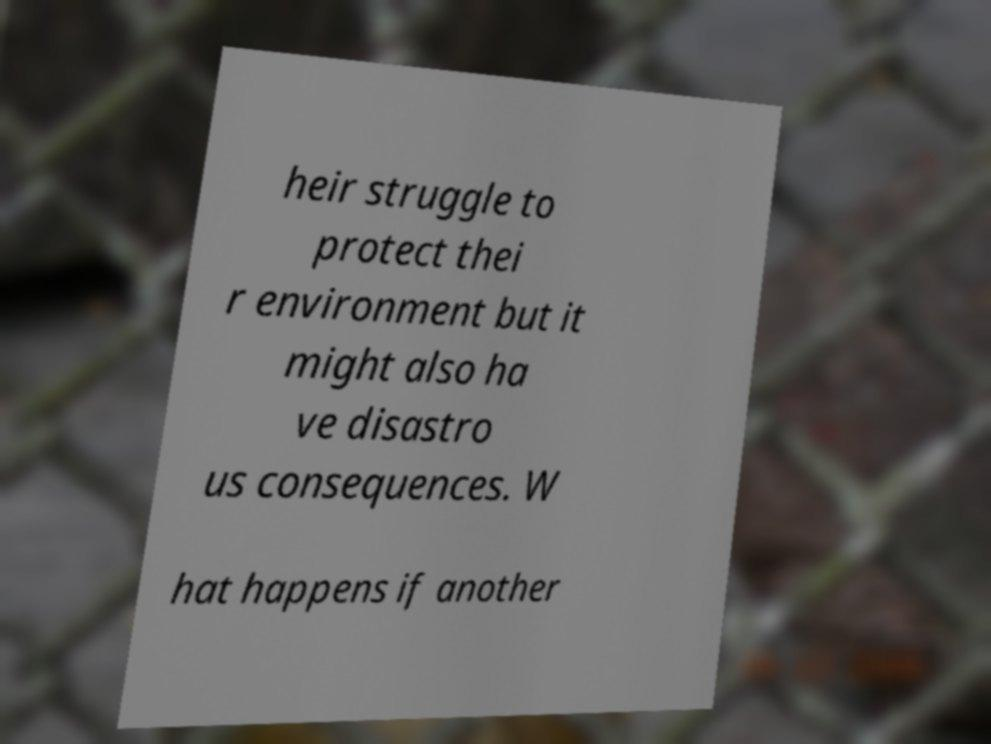Could you assist in decoding the text presented in this image and type it out clearly? heir struggle to protect thei r environment but it might also ha ve disastro us consequences. W hat happens if another 